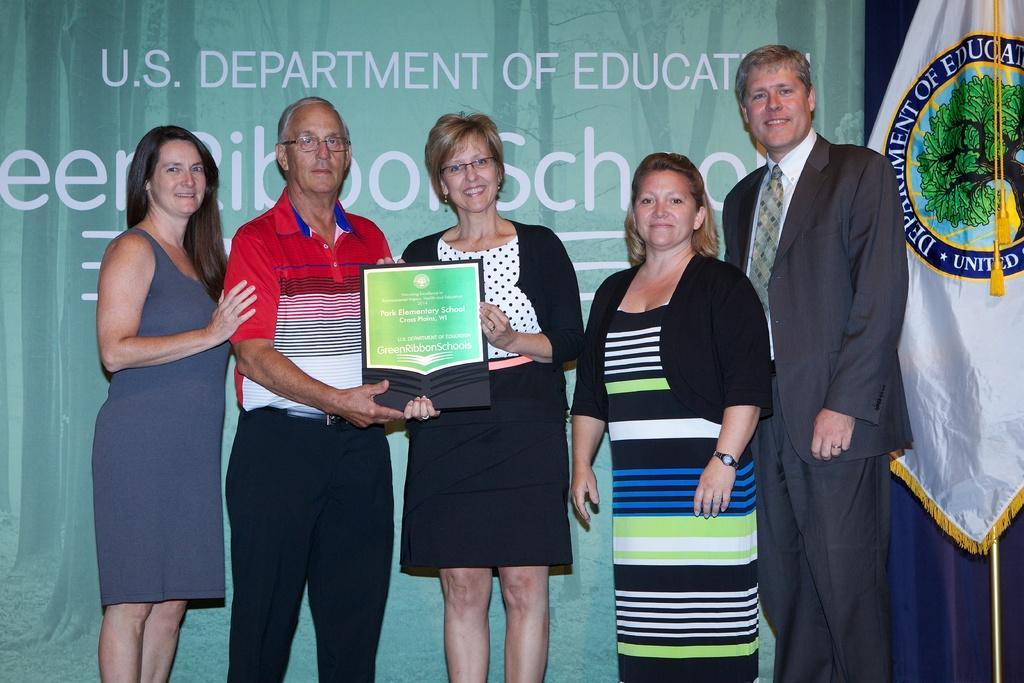How would you summarize this image in a sentence or two? In this picture there are people standing, among them there are two people holding a frame and we can see flag. In the background of the image we can see a banner. 